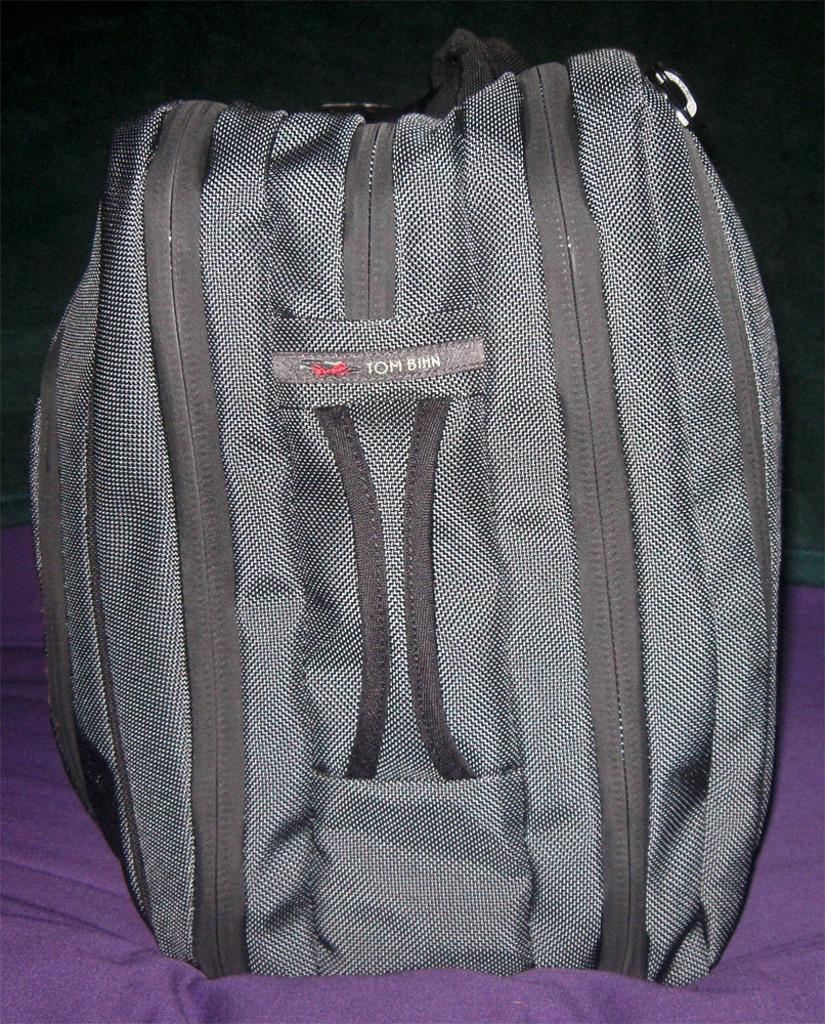What object is visible in the image? There is a backpack in the image. Where is the backpack located? The backpack is on a couch. Can you describe the color of the couch? The couch is in ash color. What type of advertisement is displayed on the property in the image? There is no advertisement or property present in the image; it only features a backpack on a couch. 